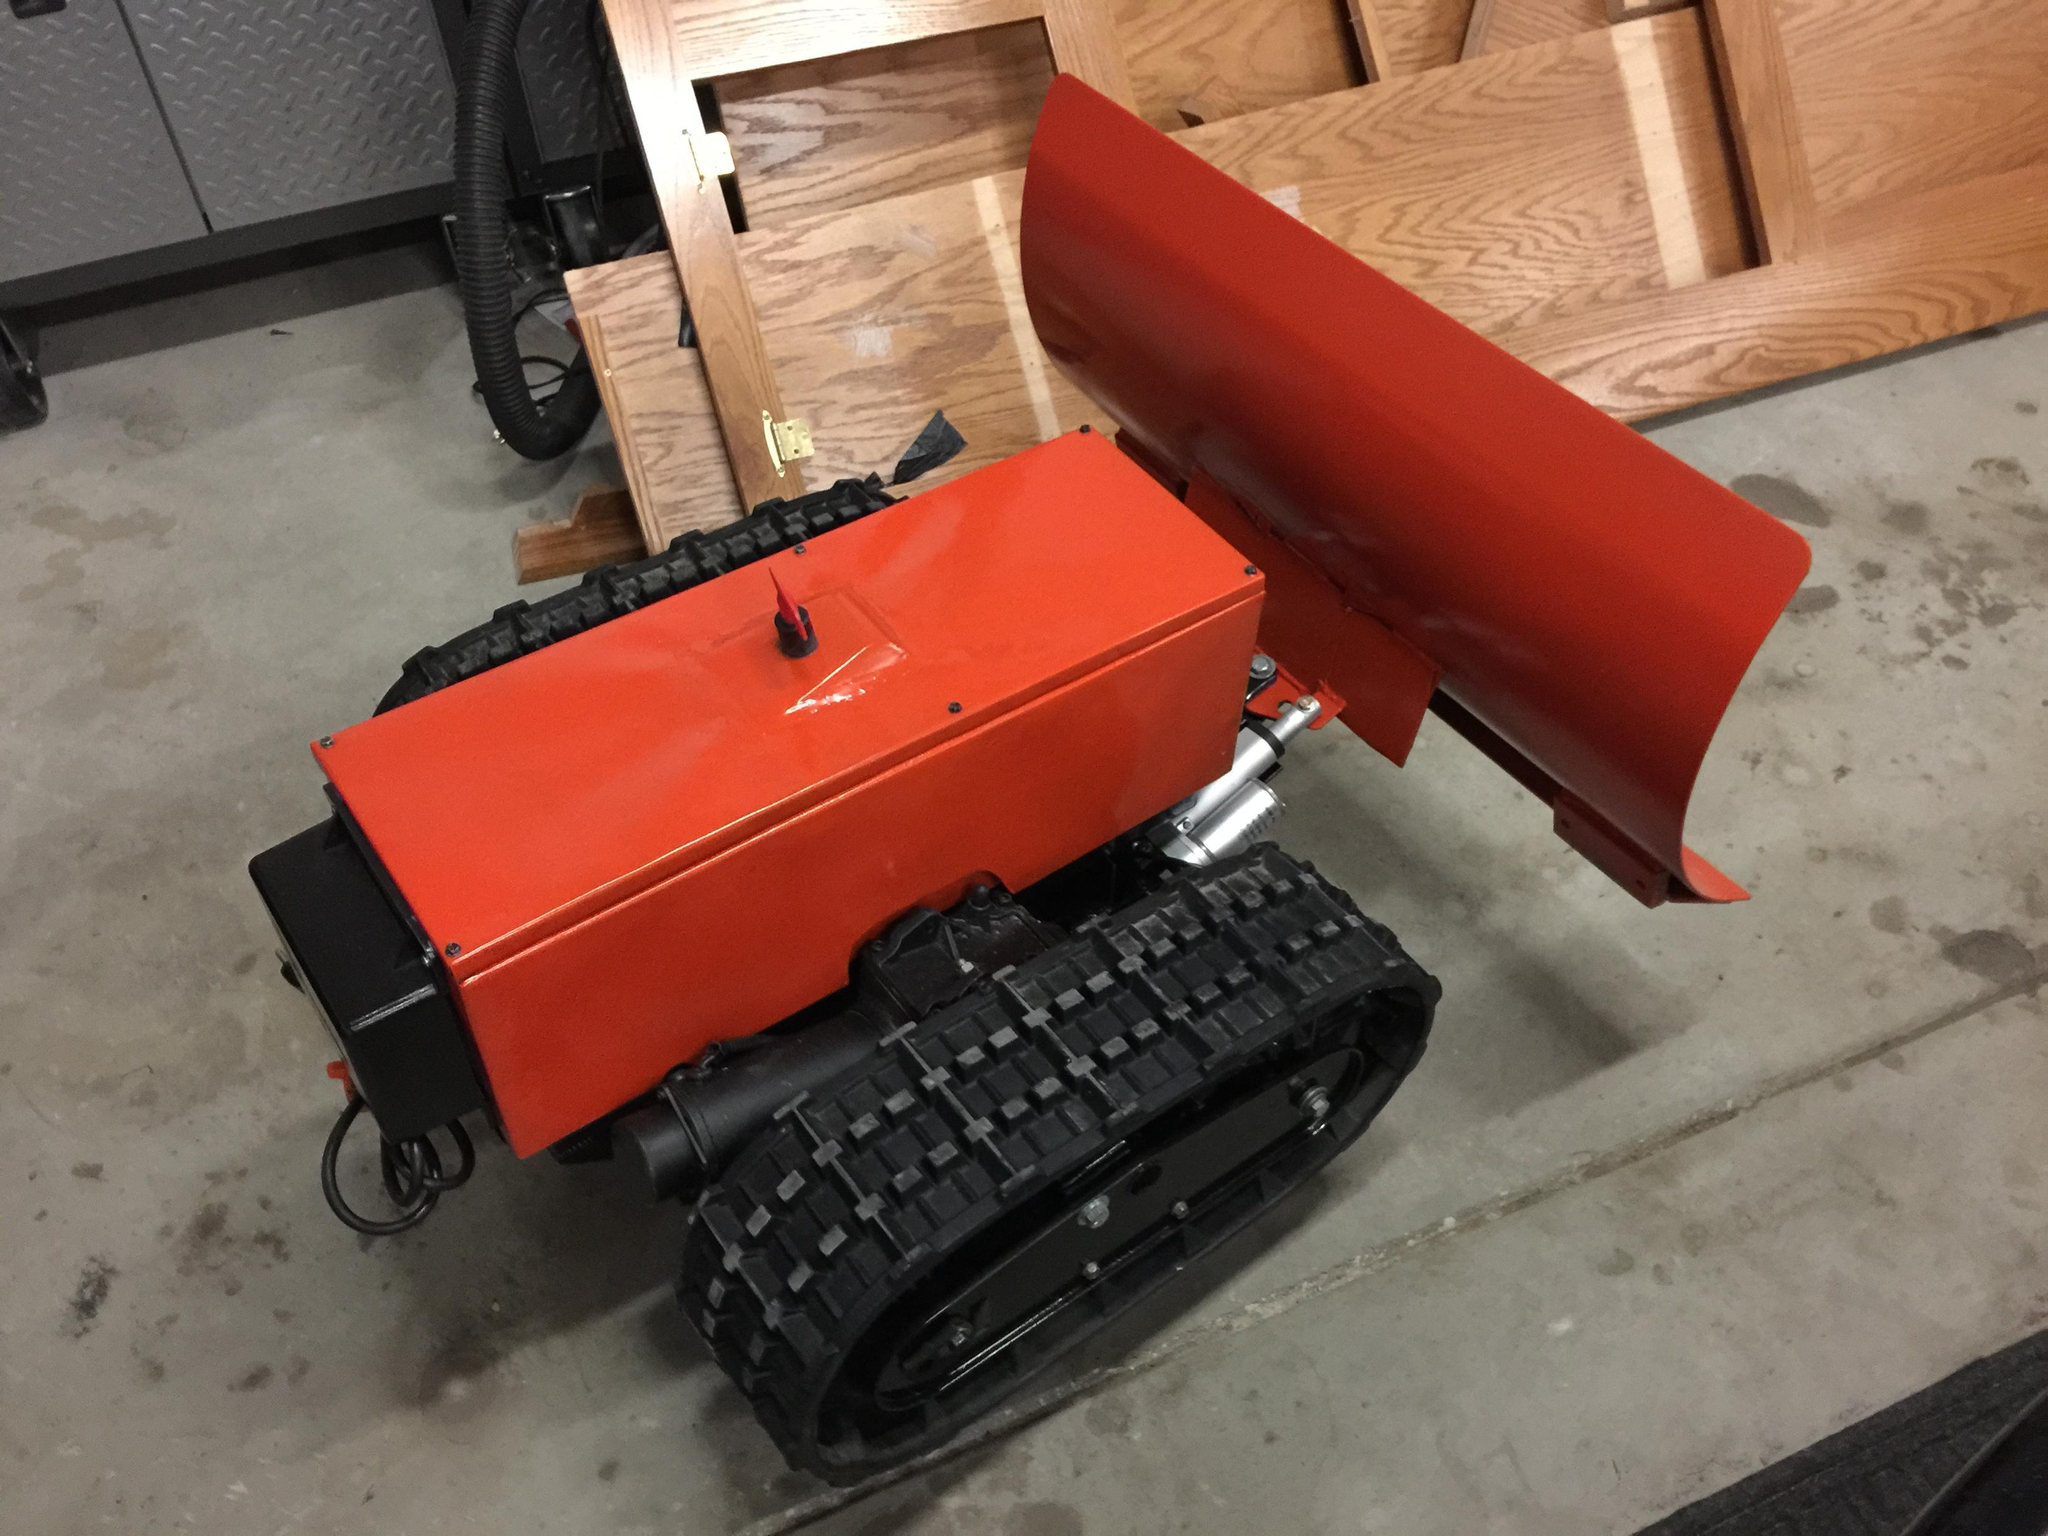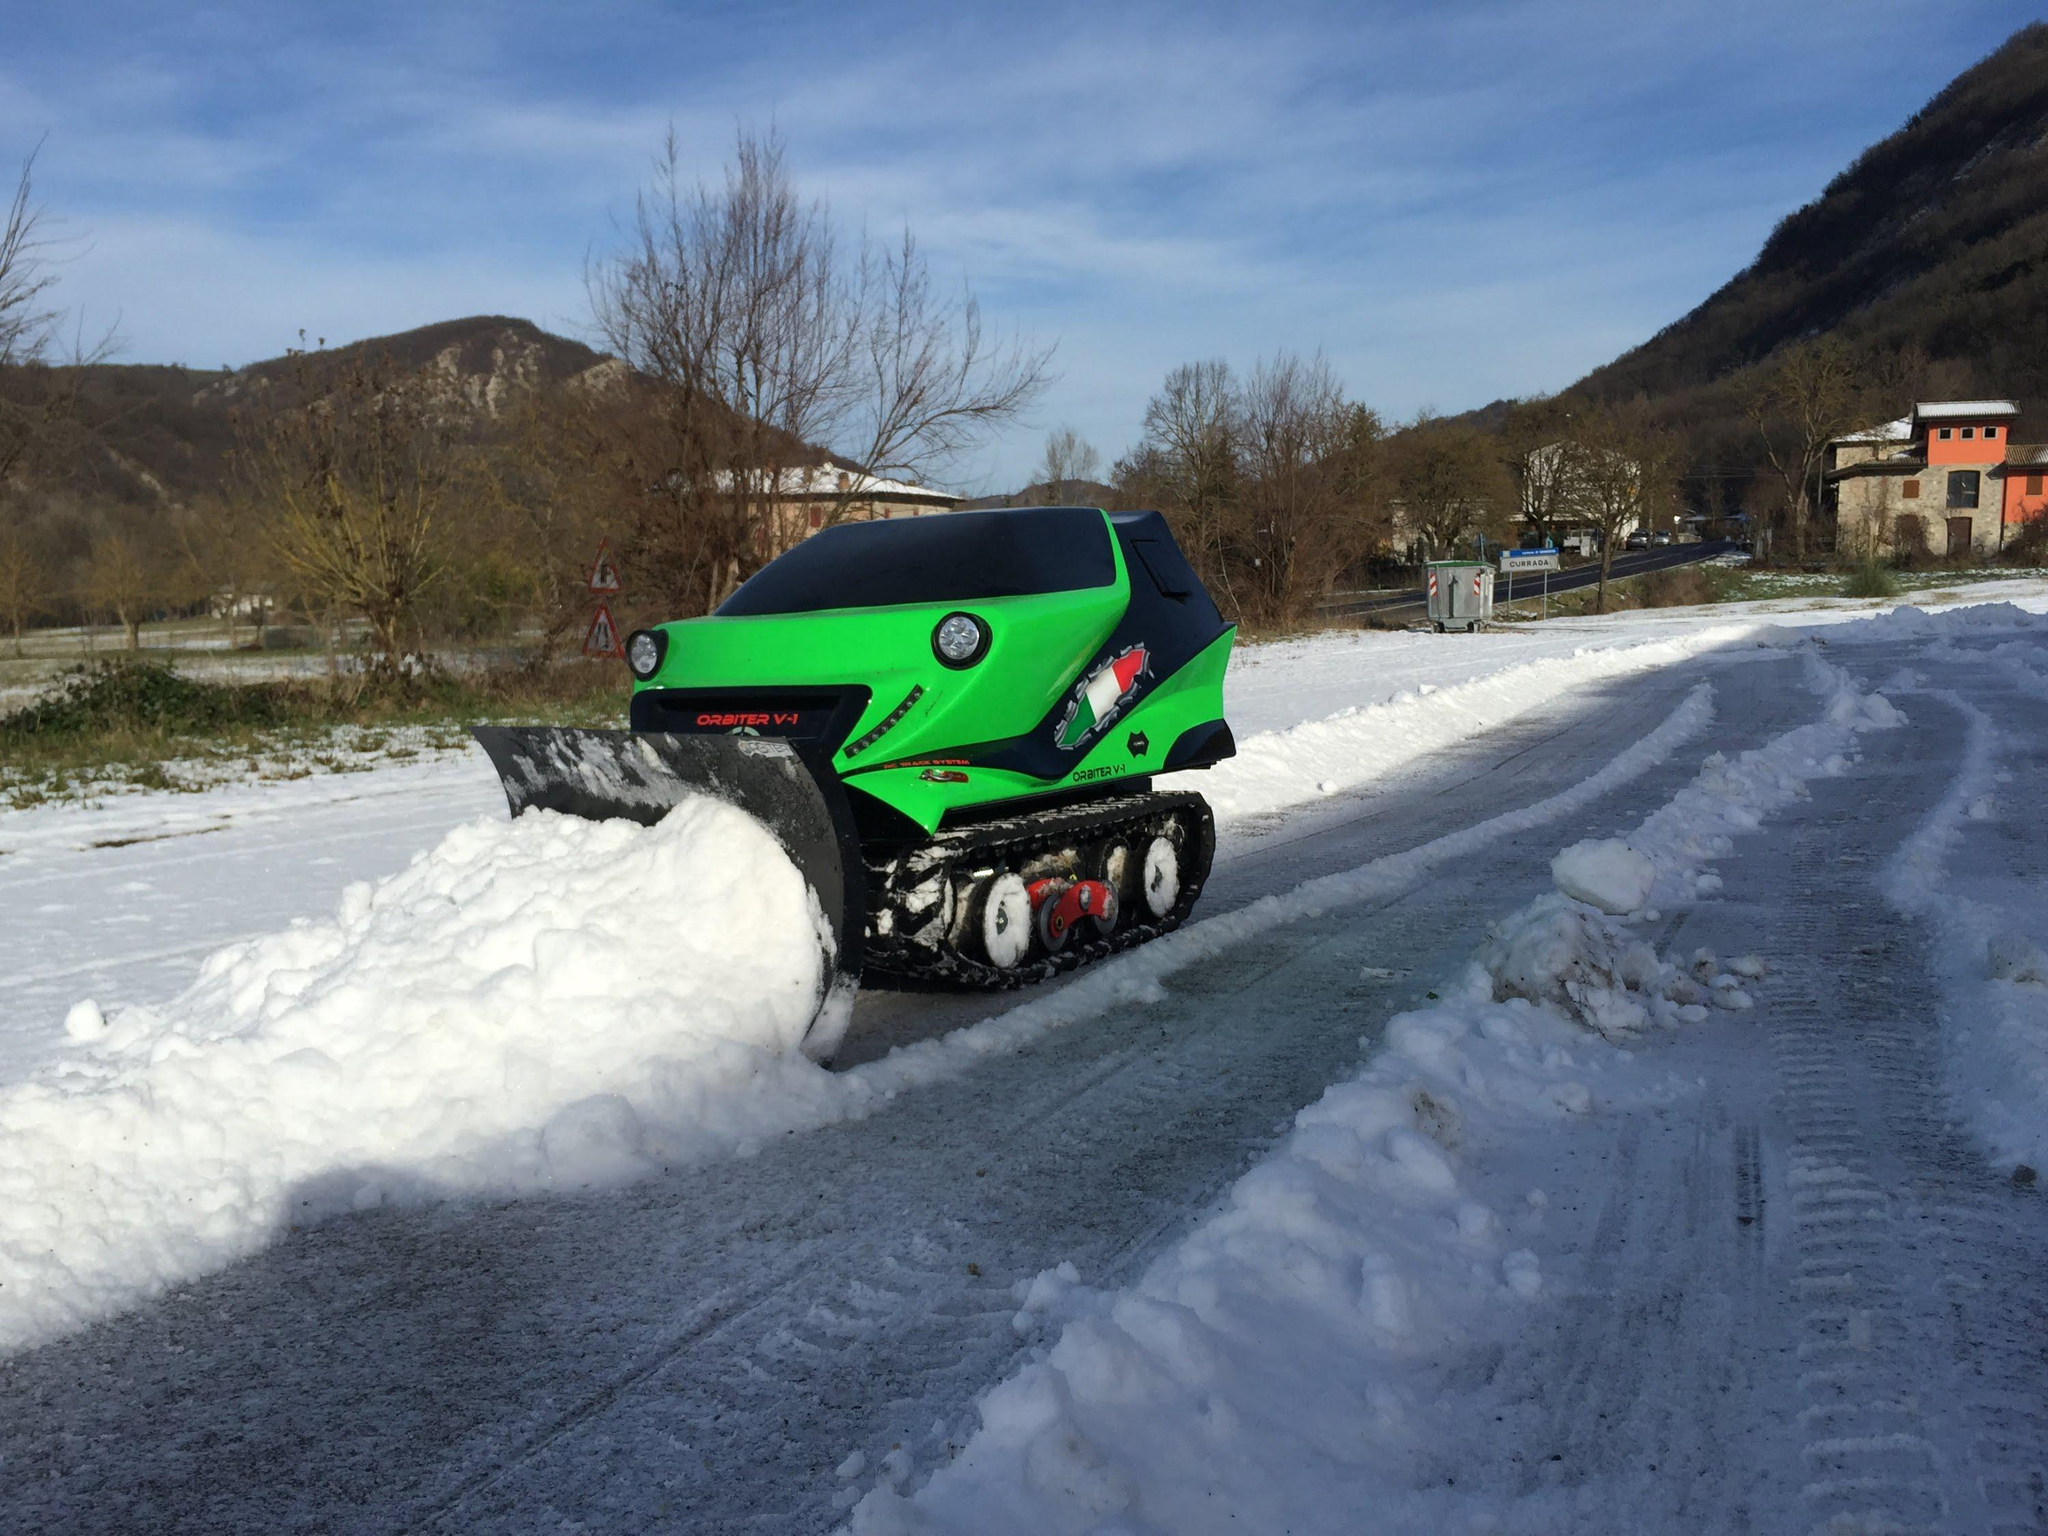The first image is the image on the left, the second image is the image on the right. Considering the images on both sides, is "The left and right image contains the same number of snow vehicle with at least one green vehicle." valid? Answer yes or no. Yes. 